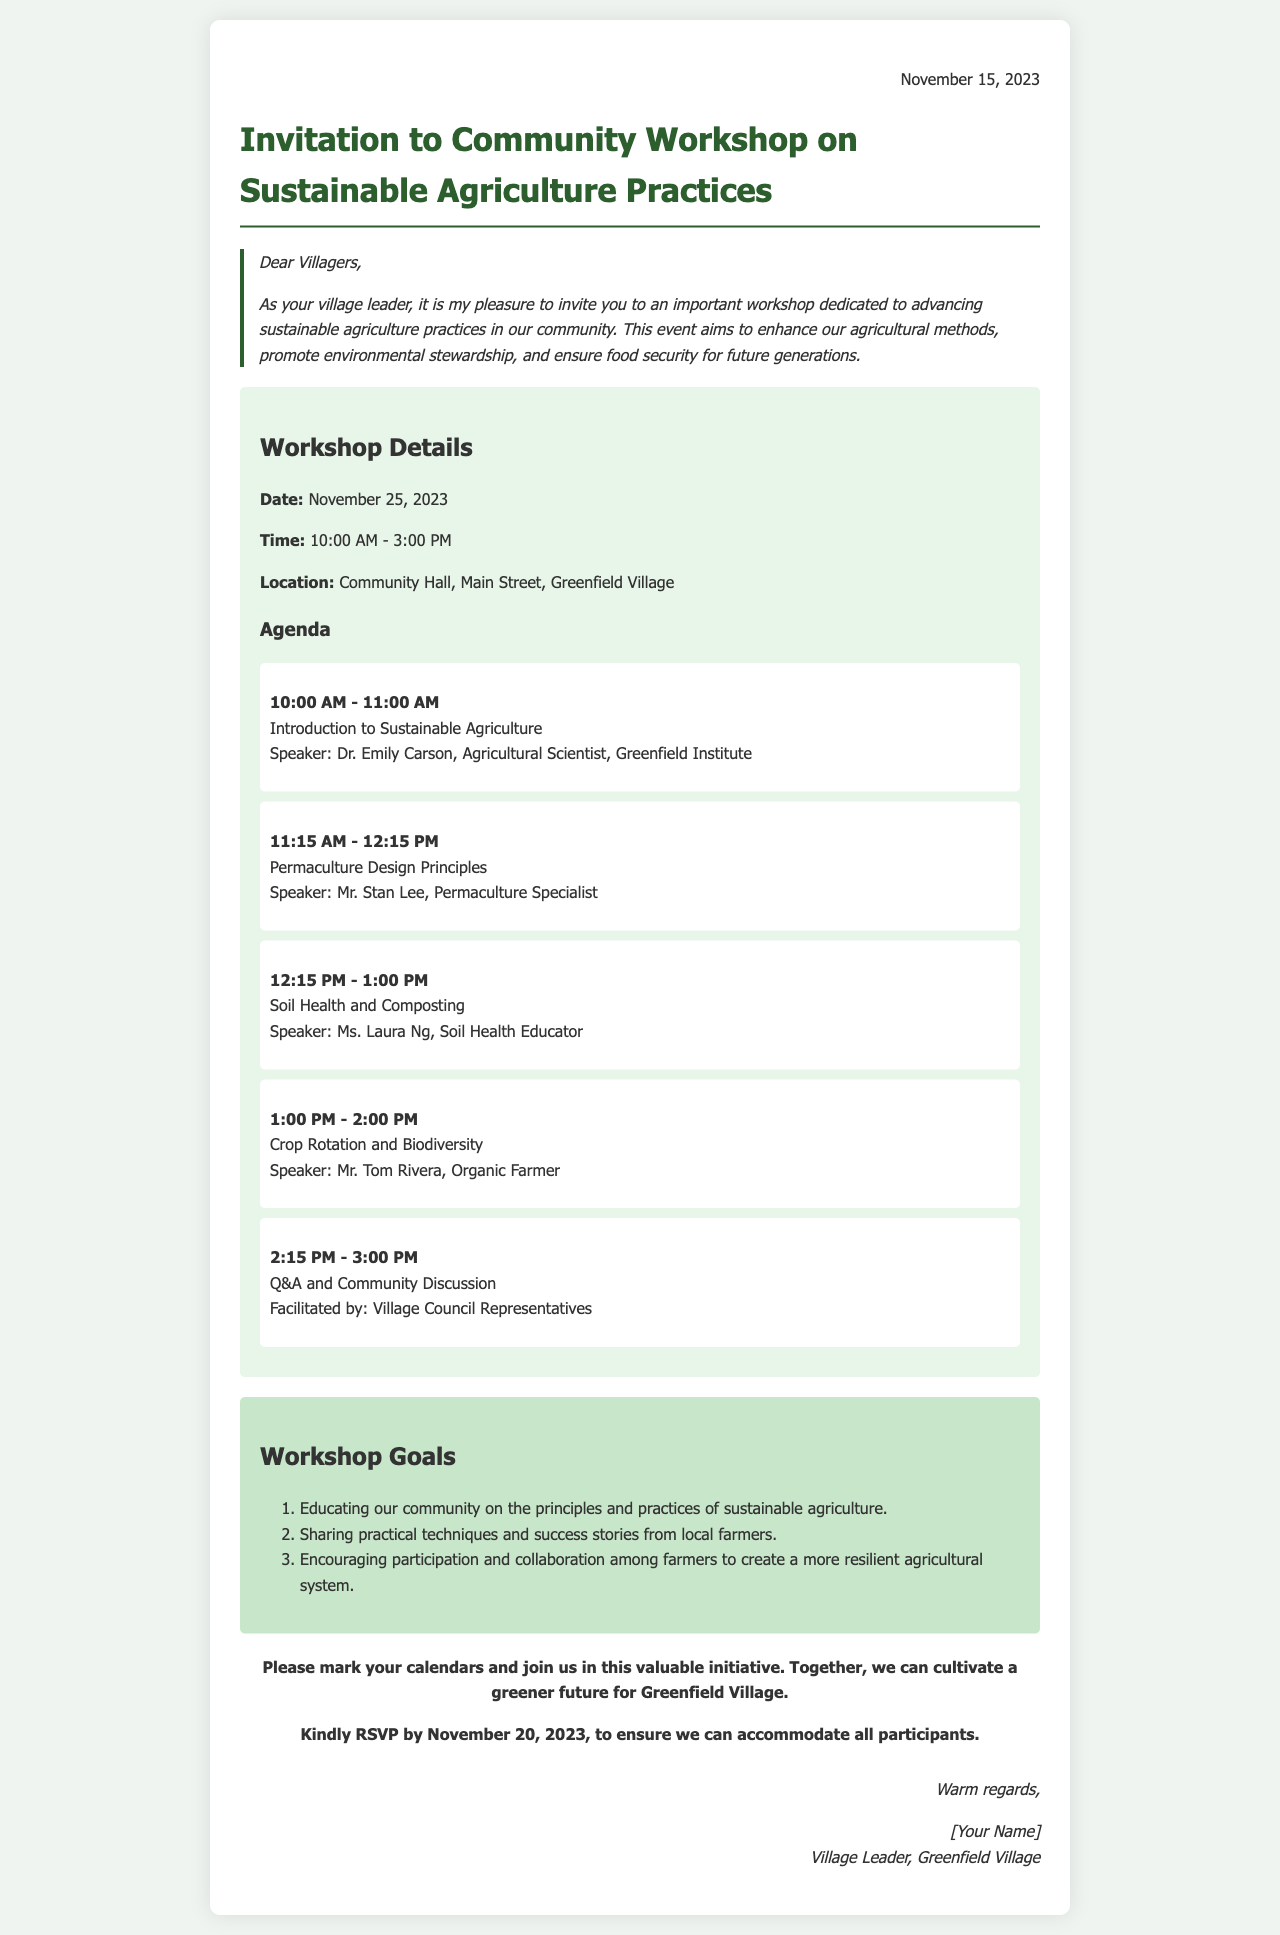What is the date of the workshop? The date of the workshop is explicitly mentioned in the workshop details.
Answer: November 25, 2023 Who is the speaker for the topic on Soil Health and Composting? The document lists the speaker for each agenda item, and for Soil Health and Composting, it is specified.
Answer: Ms. Laura Ng What time does the workshop start? The starting time of the workshop is provided in the workshop details section.
Answer: 10:00 AM What is one of the goals of the workshop? The goals of the workshop are listed in the document; any of them can be referenced as an answer.
Answer: Educating our community on the principles and practices of sustainable agriculture How long is the Q&A and Community Discussion session? The length of each agenda item, including the Q&A session, is outlined in the agenda section.
Answer: 45 minutes Where is the workshop taking place? The location of the workshop is clearly stated in the workshop details.
Answer: Community Hall, Main Street, Greenfield Village What should participants do by November 20, 2023? The call-to-action section indicates a specific task required from participants by this date.
Answer: RSVP Who is facilitating the Q&A session? The document specifies who will facilitate different parts of the workshop, including the Q&A session.
Answer: Village Council Representatives 